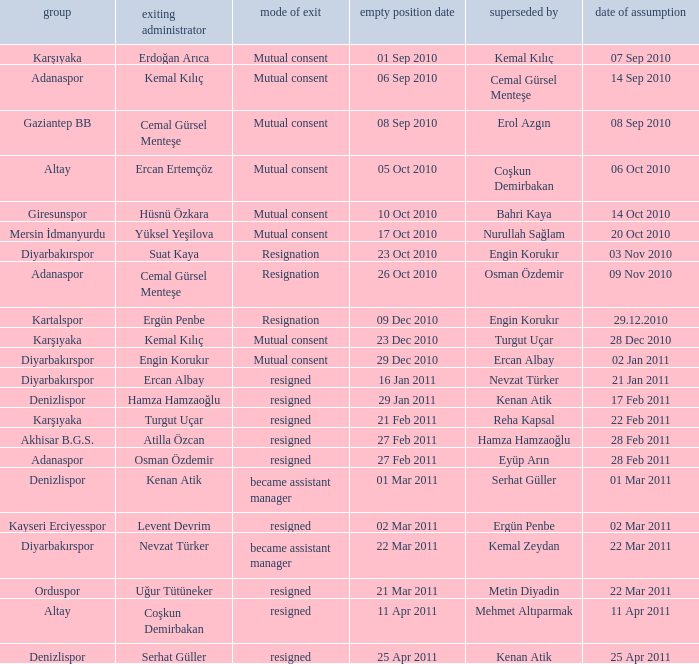When was the date of vacancy for the manager of Kartalspor?  09 Dec 2010. 